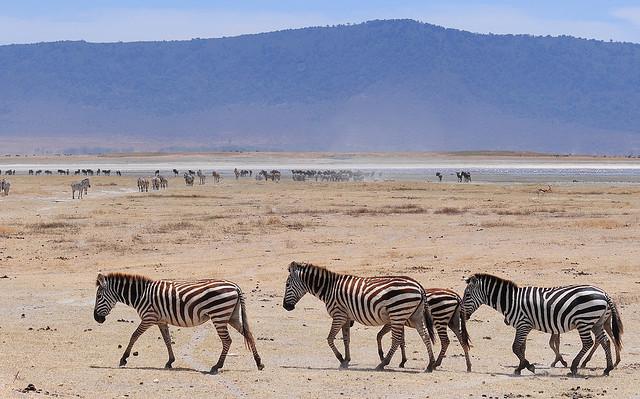Is there water in the picture?
Give a very brief answer. Yes. What type of animals are these?
Write a very short answer. Zebra. How many animals are in the foreground?
Answer briefly. 4. Where was this taken?
Answer briefly. Africa. 